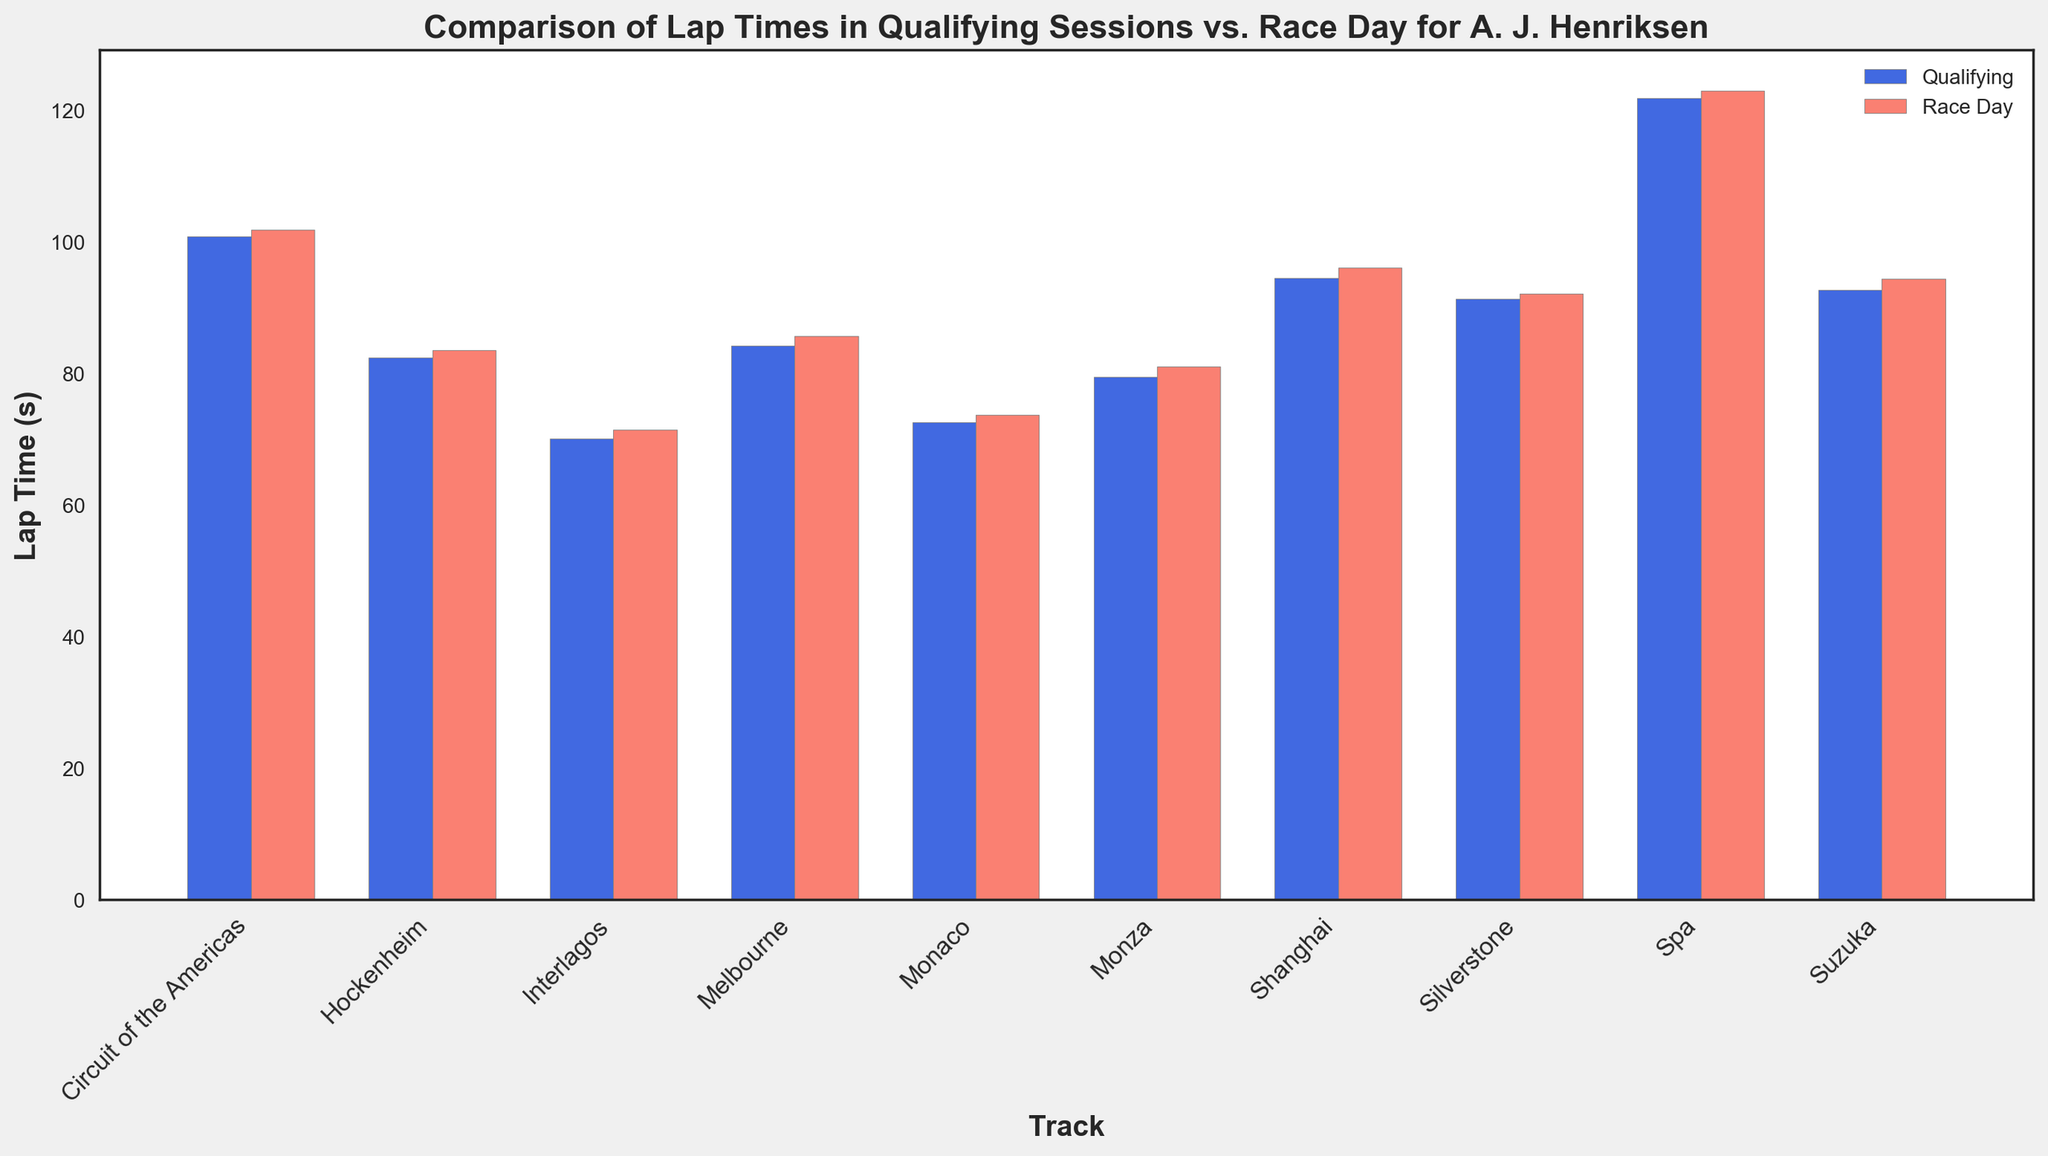What's the difference in lap time between Qualifying and Race Day at Silverstone? To find the difference, subtract the Qualifying lap time from the Race Day lap time for Silverstone. This calculation is 92.15 - 91.34 = 0.81 seconds.
Answer: 0.81 seconds Which track has the smallest difference in lap times between Qualifying and Race Day? By comparing the differences between Qualifying and Race Day lap times for each track visually, Monaco has the smallest difference with times 72.56 seconds (Qualifying) and 73.72 seconds (Race Day). Calculate 73.72 - 72.56 = 1.16 seconds, which is the smallest among all tracks.
Answer: Monaco On which track did A. J. Henriksen have the fastest Race Day lap time? By looking at the height of the red (Race Day) bars and identifying the shortest one, Interlagos has the fastest Race Day lap time at 71.43 seconds.
Answer: Interlagos Was A. J. Henriksen generally faster during Qualifying or Race Day across all tracks? By comparing the blue (Qualifying) and red (Race Day) bars at each track, the blue bars are consistently lower, indicating shorter times. Therefore, A. J. Henriksen was generally faster during Qualifying across all tracks.
Answer: Qualifying How much slower was A. J. Henriksen at Spa on Race Day compared to Qualifying? To determine how much slower he was, subtract the Qualifying lap time from the Race Day lap time for Spa. This calculation is 123.03 - 121.88 = 1.15 seconds.
Answer: 1.15 seconds Which track has the largest gap between Qualifying and Race Day lap times? Visually identifying the largest gap between the blue and red bars, the largest gap exists at Melbourne. Comparing their times, 85.67 seconds (Race Day) and 84.24 seconds (Qualifying), results in a gap of 85.67 - 84.24 = 1.43 seconds.
Answer: Melbourne List the tracks where the lap time difference between Qualifying and Race Day is greater than 1 second. Inspect each track and calculate the difference: Silverstone (0.81), Monza (1.56), Spa (1.15), Suzuka (1.74), Monaco (1.16), Interlagos (1.32), Melbourne (1.43), Circuit of the Americas (1.10), Hockenheim (1.13), Shanghai (1.51). All except Silverstone have more than 1 second difference. The tracks are Monza, Spa, Suzuka, Monaco, Interlagos, Melbourne, Circuit of the Americas, Hockenheim, and Shanghai.
Answer: Monza, Spa, Suzuka, Monaco, Interlagos, Melbourne, Circuit of the Americas, Hockenheim, and Shanghai Among the tracks with the largest Race Day lap times, which one ranks highest? Comparing the heights of the red (Race Day) bars, Spa has the highest, indicating the longest Race Day lap time at 123.03 seconds.
Answer: Spa Which track has the smallest Race Day lap time? Checking the heights of the red (Race Day) bars, Interlagos has the smallest Race Day lap time at 71.43 seconds.
Answer: Interlagos If you wanted to calculate the average Qualifying lap time across all tracks, how would you proceed? Add up all the Qualifying lap times (91.34 + 79.42 + 121.88 + 92.67 + 72.56 + 70.11 + 84.24 + 100.79 + 82.34 + 94.51) and divide by the number of tracks (10). The sum is 890.86, thus the average is 890.86 / 10 = 89.086 seconds.
Answer: 89.086 seconds 